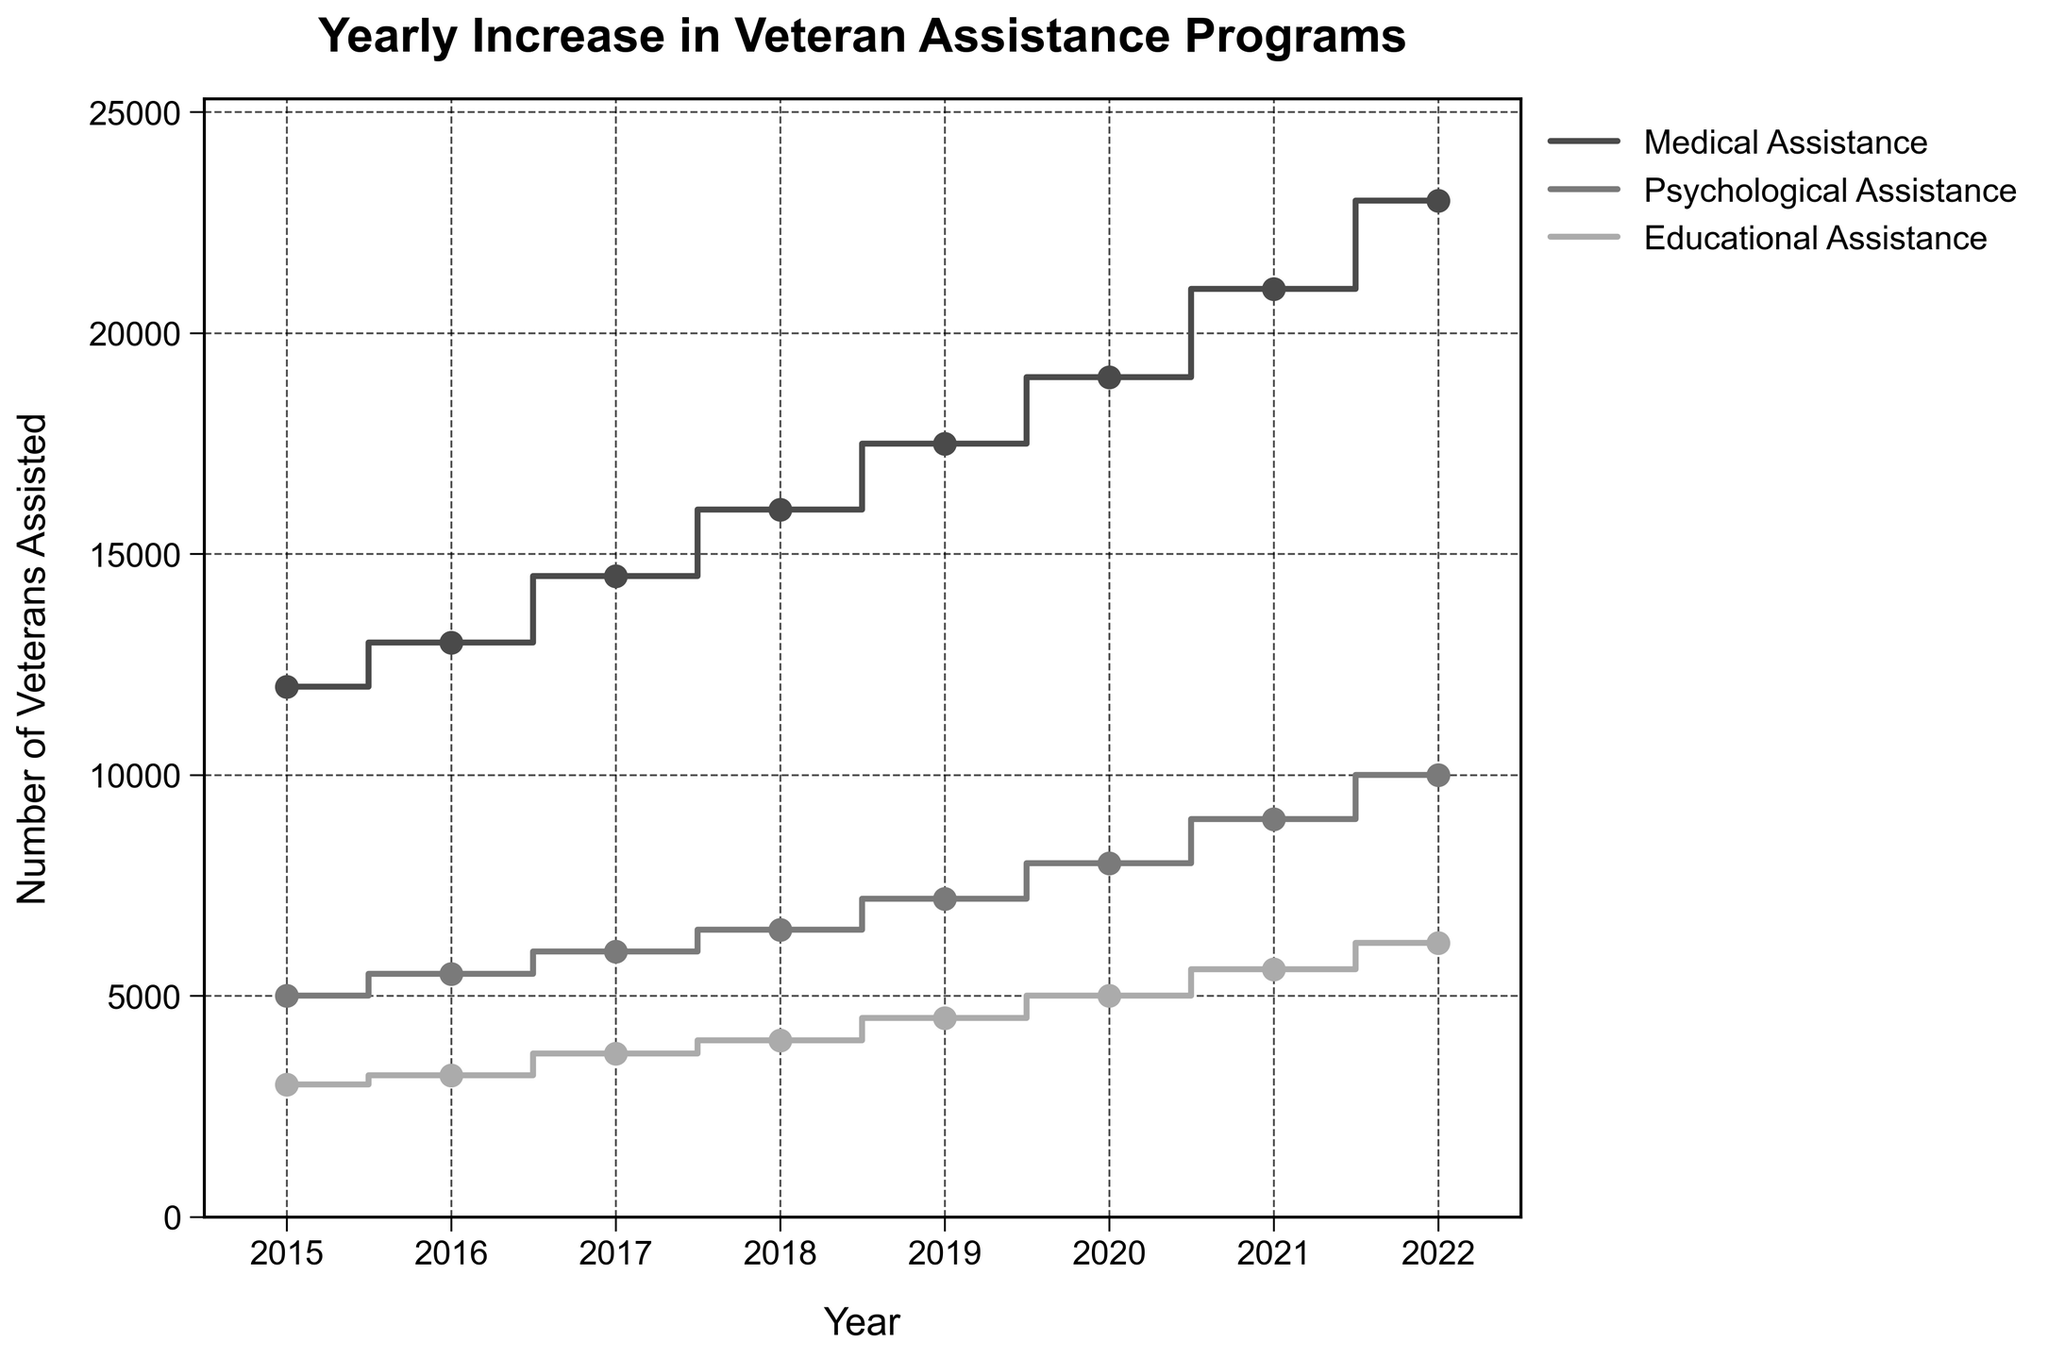what is the title of the figure? The title of the figure is located at the top center, and it reads: "Yearly Increase in Veteran Assistance Programs".
Answer: Yearly Increase in Veteran Assistance Programs How many types of veteran assistance programs are shown in the plot? The figure displays three types of veteran assistance programs, which can be identified in the legend on the right.
Answer: Three Which type of assistance program had the highest number of veterans assisted in 2022? By looking at the endpoints of the steps in the year 2022, the Medical Assistance category shows the highest number of veterans assisted, as it reaches the highest value.
Answer: Medical Assistance What is the difference in the number of veterans assisted between Medical Assistance and Educational Assistance in 2020? In 2020, Medical Assistance had 19,000 veterans, and Educational Assistance had 5,000 veterans. Subtracting the latter from the former gives the difference: 19,000 - 5,000 = 14,000.
Answer: 14,000 Between which consecutive years did Psychological Assistance see the greatest increase in the number of veterans assisted? By observing the step heights for Psychological Assistance, the biggest jump occurs between 2021 and 2022, going from 9,000 to 10,000, reflecting a 1,000 increase.
Answer: 2021 and 2022 How many total veterans were assisted through all programs in 2019? The total number of veterans assisted in 2019 can be calculated by adding the values of all three programs: 17,500 (Medical) + 7,200 (Psychological) + 4,500 (Educational) = 29,200.
Answer: 29,200 What is the average number of veterans assisted across all programs in 2018? Sum the values for 2018: 16,000 (Medical) + 6,500 (Psychological) + 4,000 (Educational) = 26,500. Then divide by the number of programs, which is three. The average is 26,500 / 3 ≈ 8,833.33.
Answer: ~8,833.33 Did any type of assistance program have a decrease in the number of veterans assisted over the years? The plot shows that all the steps for each category are increasing upwards each year, implying that none of the assistance programs experienced a decrease.
Answer: No Which year had the smallest increase in veterans assisted for Psychological Assistance? By comparing the vertical lengths of the steps for Psychological Assistance, the smallest increase occurred between 2016 and 2017, where the number increased from 5,500 to 6,000 (only a 500 increase).
Answer: 2016 to 2017 How does the growth trend of Educational Assistance compare to Medical Assistance from 2015 to 2022? While both show an increasing trend, Medical Assistance grows at a much steeper rate than Educational Assistance, indicating a higher rate of growth over the same period.
Answer: Steeper rate for Medical Assistance 